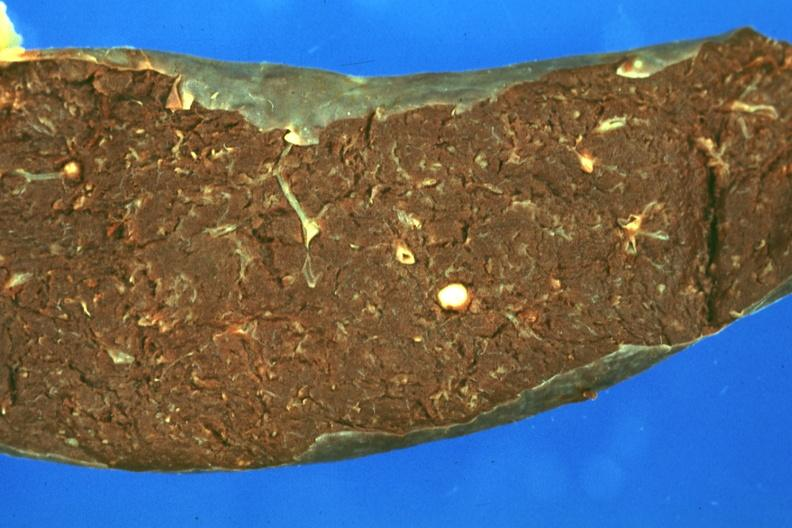s palmar crease normal present?
Answer the question using a single word or phrase. No 